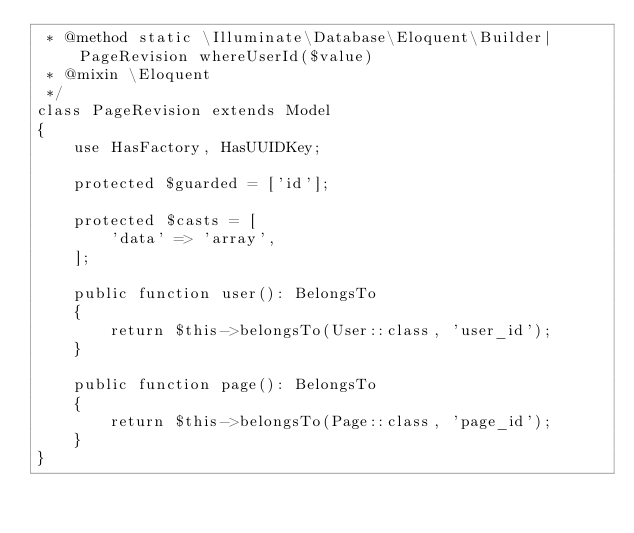<code> <loc_0><loc_0><loc_500><loc_500><_PHP_> * @method static \Illuminate\Database\Eloquent\Builder|PageRevision whereUserId($value)
 * @mixin \Eloquent
 */
class PageRevision extends Model
{
    use HasFactory, HasUUIDKey;

    protected $guarded = ['id'];

    protected $casts = [
        'data' => 'array',
    ];

    public function user(): BelongsTo
    {
        return $this->belongsTo(User::class, 'user_id');
    }

    public function page(): BelongsTo
    {
        return $this->belongsTo(Page::class, 'page_id');
    }
}
</code> 